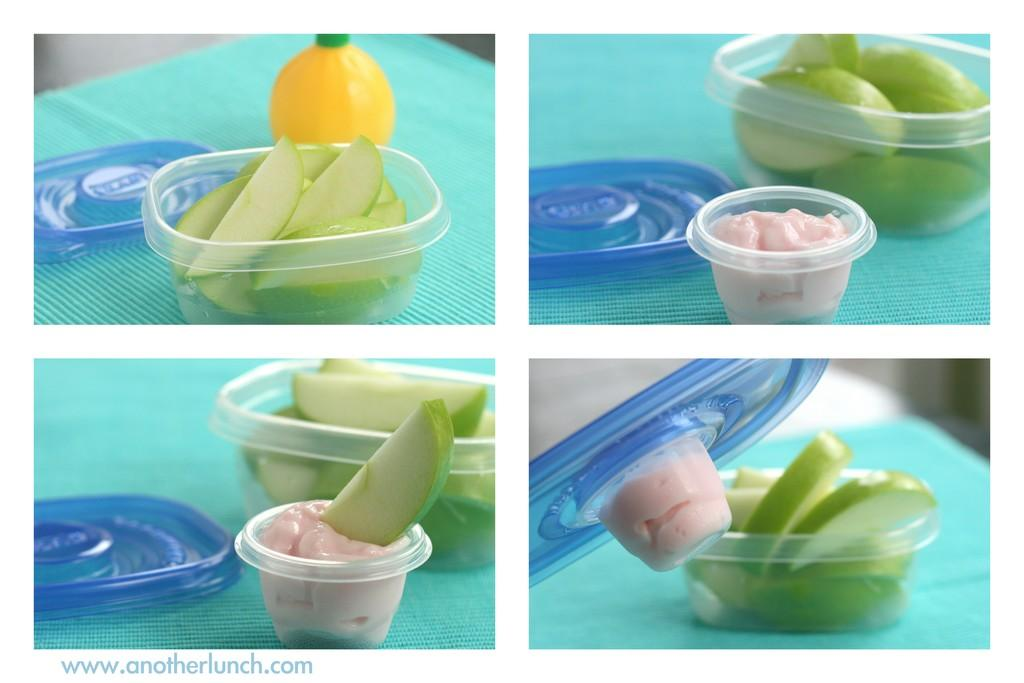What types of items are featured in the collage in the image? The image contains a collage of fruits and spices. How are the fruits and spices arranged in the image? The fruits and spices are placed in plastic tubs. What type of polish is being applied to the lunchroom table in the image? There is no lunchroom table or polish present in the image; it features a collage of fruits and spices in plastic tubs. 